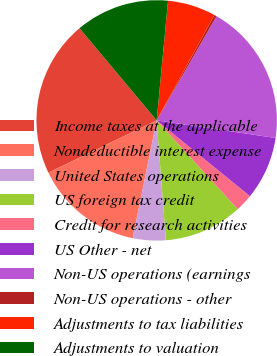Convert chart to OTSL. <chart><loc_0><loc_0><loc_500><loc_500><pie_chart><fcel>Income taxes at the applicable<fcel>Nondeductible interest expense<fcel>United States operations<fcel>US foreign tax credit<fcel>Credit for research activities<fcel>US Other - net<fcel>Non-US operations (earnings<fcel>Non-US operations - other<fcel>Adjustments to tax liabilities<fcel>Adjustments to valuation<nl><fcel>21.07%<fcel>14.64%<fcel>4.42%<fcel>10.55%<fcel>2.38%<fcel>8.51%<fcel>19.03%<fcel>0.33%<fcel>6.47%<fcel>12.6%<nl></chart> 